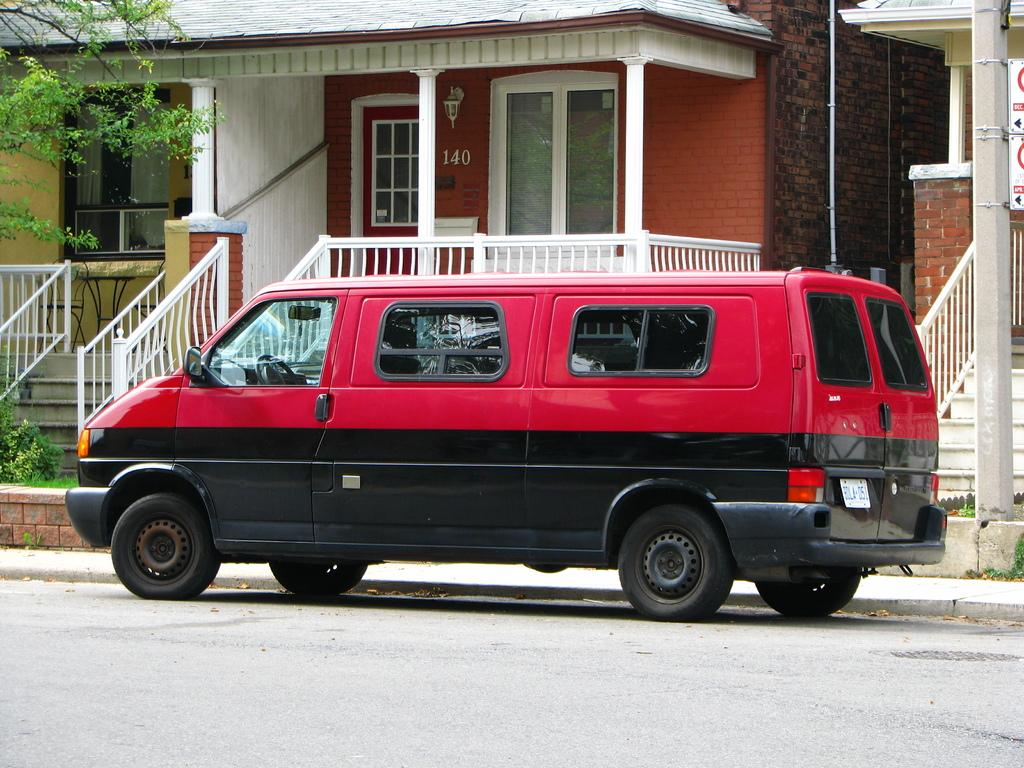What is parked in the image? There is a vehicle parked in the image. Where is the vehicle parked? The vehicle is parked on the side of a road. What can be seen in the background of the image? There is a building in the background of the image. Is there any vegetation visible in the image? Yes, there is a tree beside the building in the background. How many toes can be seen in the image? There are no toes visible in the image. 